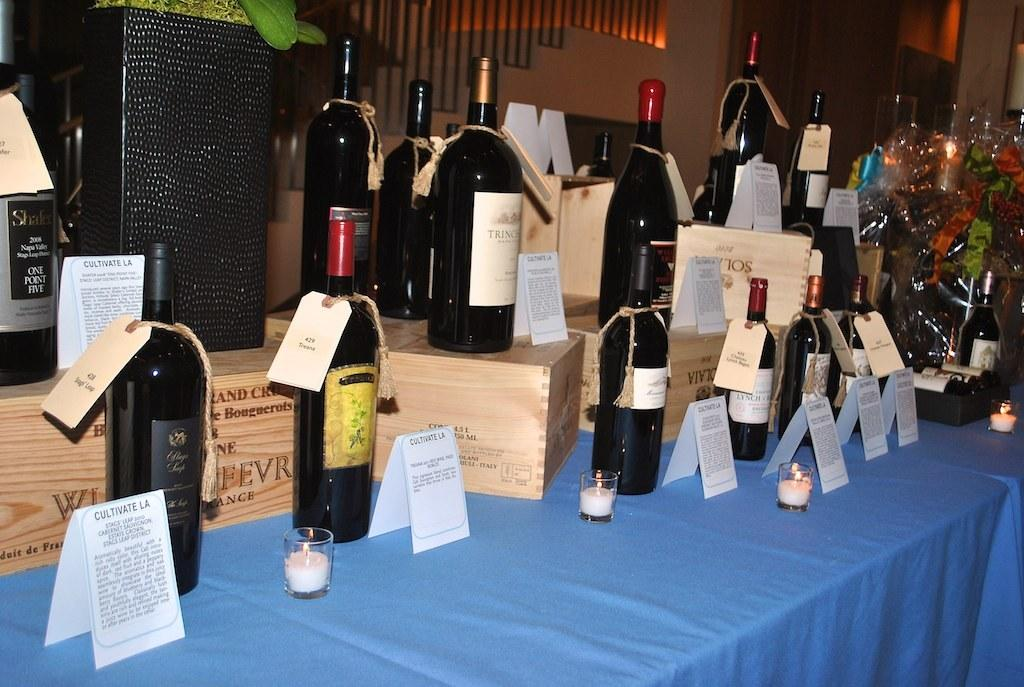<image>
Give a short and clear explanation of the subsequent image. A whole bunch of white bottles on a table with Cultivate LA cards in front of them. 